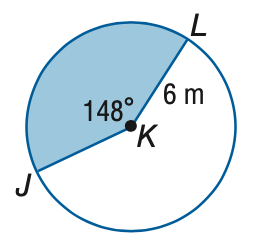Question: Find the area of the shaded sector. Round to the nearest tenth.
Choices:
A. 15.5
B. 46.5
C. 66.6
D. 113.1
Answer with the letter. Answer: B 